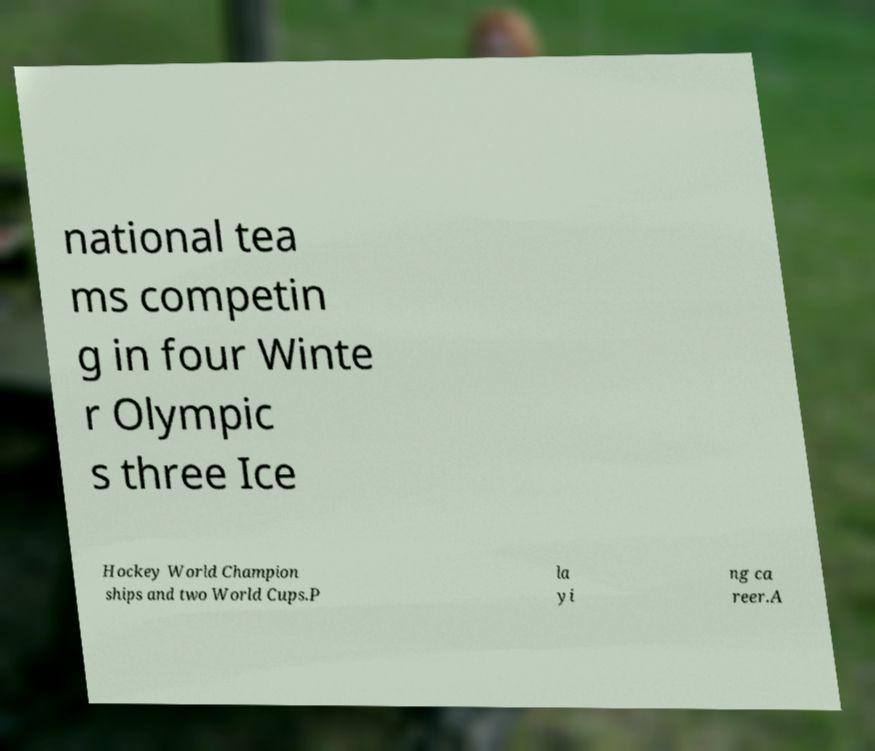Could you extract and type out the text from this image? national tea ms competin g in four Winte r Olympic s three Ice Hockey World Champion ships and two World Cups.P la yi ng ca reer.A 